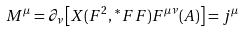Convert formula to latex. <formula><loc_0><loc_0><loc_500><loc_500>M ^ { \mu } = \partial _ { \nu } \left [ X ( F ^ { 2 } , \, ^ { * } F F ) F ^ { \mu \nu } ( A ) \right ] = j ^ { \mu }</formula> 